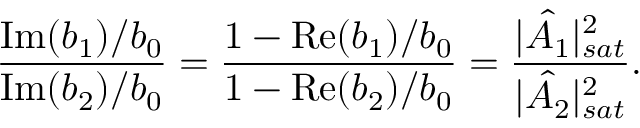Convert formula to latex. <formula><loc_0><loc_0><loc_500><loc_500>\frac { I m ( b _ { 1 } ) / b _ { 0 } } { I m ( b _ { 2 } ) / b _ { 0 } } = \frac { 1 - R e ( b _ { 1 } ) / b _ { 0 } } { 1 - R e ( b _ { 2 } ) / b _ { 0 } } = \frac { | \hat { A _ { 1 } } | _ { s a t } ^ { 2 } } { | \hat { A _ { 2 } } | _ { s a t } ^ { 2 } } .</formula> 